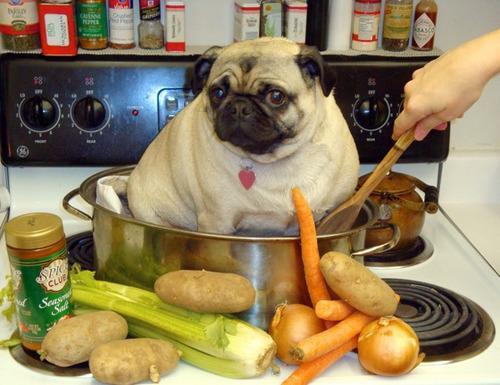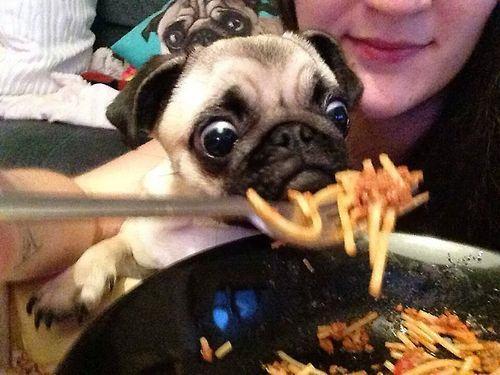The first image is the image on the left, the second image is the image on the right. Evaluate the accuracy of this statement regarding the images: "A dog is eating a plain cheese pizza in at least one of the images.". Is it true? Answer yes or no. No. The first image is the image on the left, the second image is the image on the right. Given the left and right images, does the statement "A chubby beige pug is sitting in a container in one image, and the other image shows a pug with orange food in front of its mouth." hold true? Answer yes or no. Yes. 